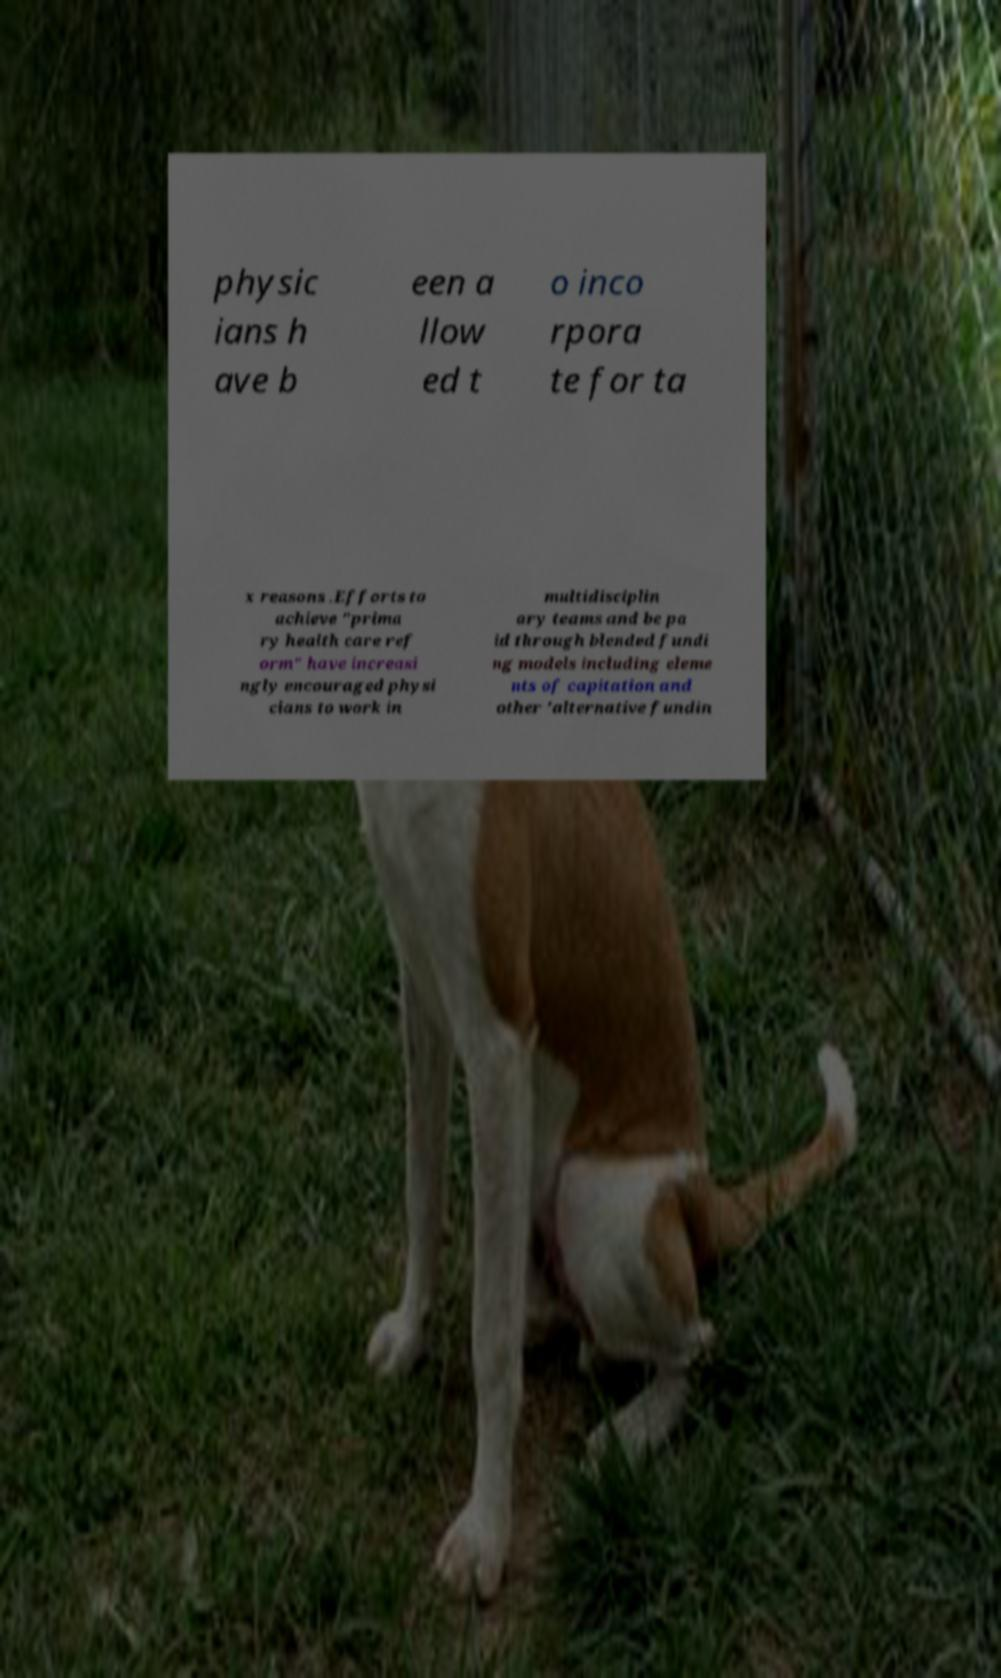Can you read and provide the text displayed in the image?This photo seems to have some interesting text. Can you extract and type it out for me? physic ians h ave b een a llow ed t o inco rpora te for ta x reasons .Efforts to achieve "prima ry health care ref orm" have increasi ngly encouraged physi cians to work in multidisciplin ary teams and be pa id through blended fundi ng models including eleme nts of capitation and other 'alternative fundin 